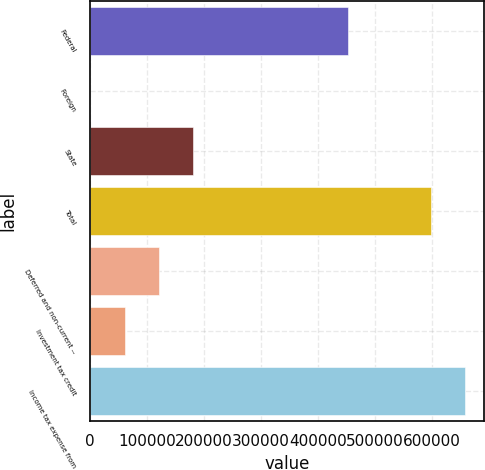Convert chart. <chart><loc_0><loc_0><loc_500><loc_500><bar_chart><fcel>Federal<fcel>Foreign<fcel>State<fcel>Total<fcel>Deferred and non-current --<fcel>Investment tax credit<fcel>Income tax expense from<nl><fcel>451517<fcel>256<fcel>181079<fcel>597944<fcel>120804<fcel>60530.2<fcel>658218<nl></chart> 